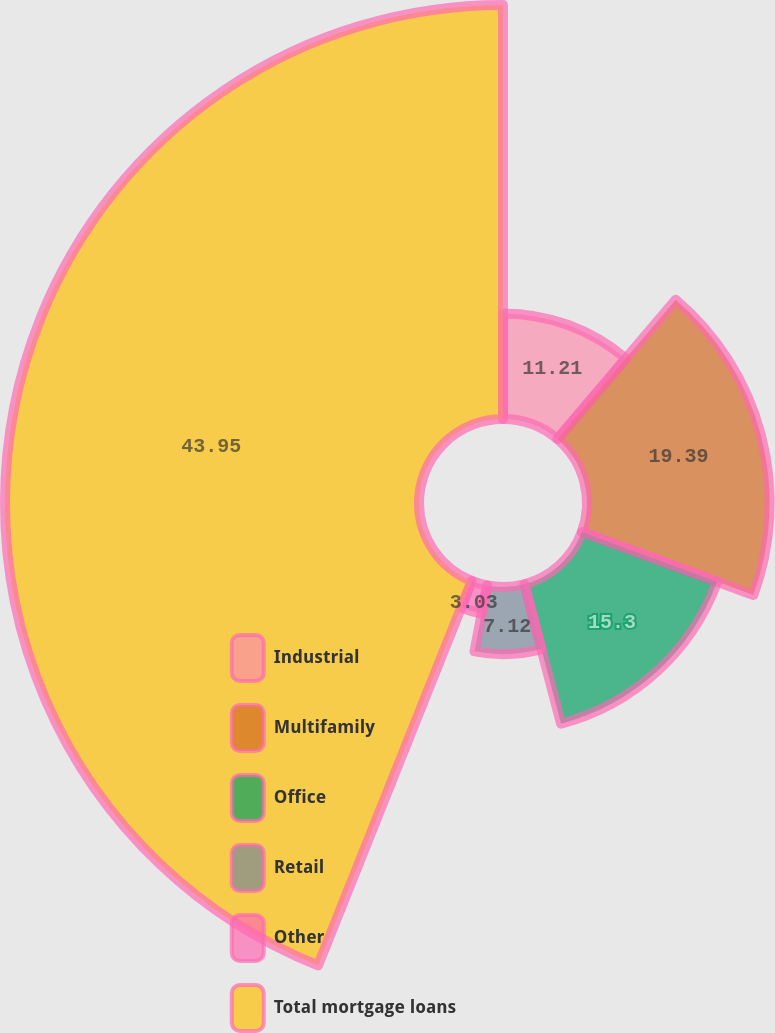Convert chart. <chart><loc_0><loc_0><loc_500><loc_500><pie_chart><fcel>Industrial<fcel>Multifamily<fcel>Office<fcel>Retail<fcel>Other<fcel>Total mortgage loans<nl><fcel>11.21%<fcel>19.39%<fcel>15.3%<fcel>7.12%<fcel>3.03%<fcel>43.94%<nl></chart> 